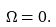<formula> <loc_0><loc_0><loc_500><loc_500>\Omega = 0 .</formula> 